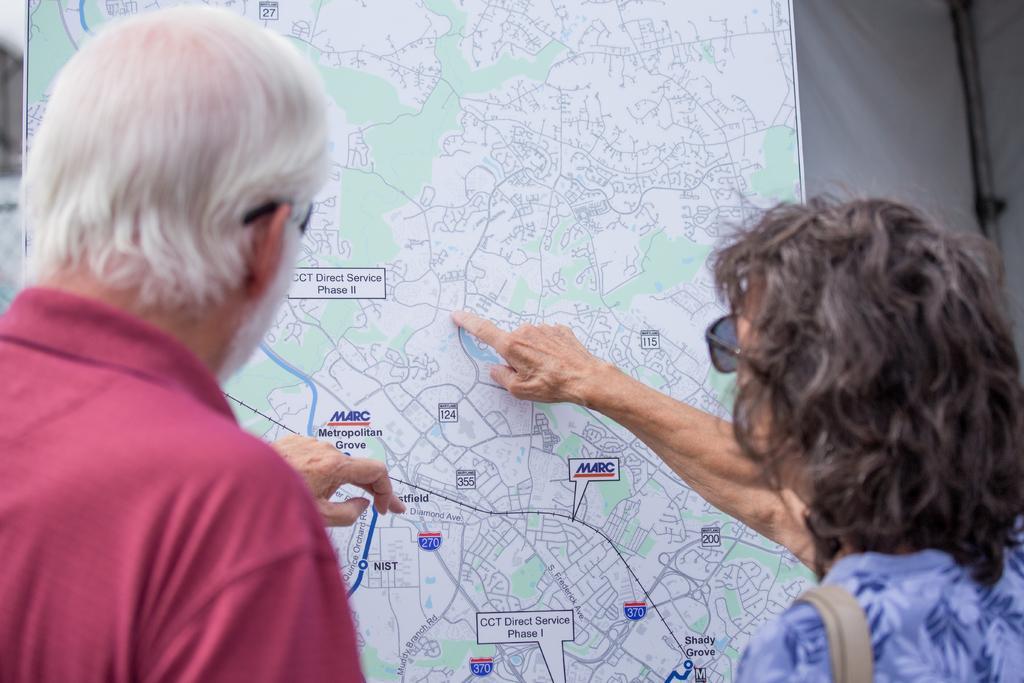Could you give a brief overview of what you see in this image? In this image I can see a man and a lady looking at the route map. 